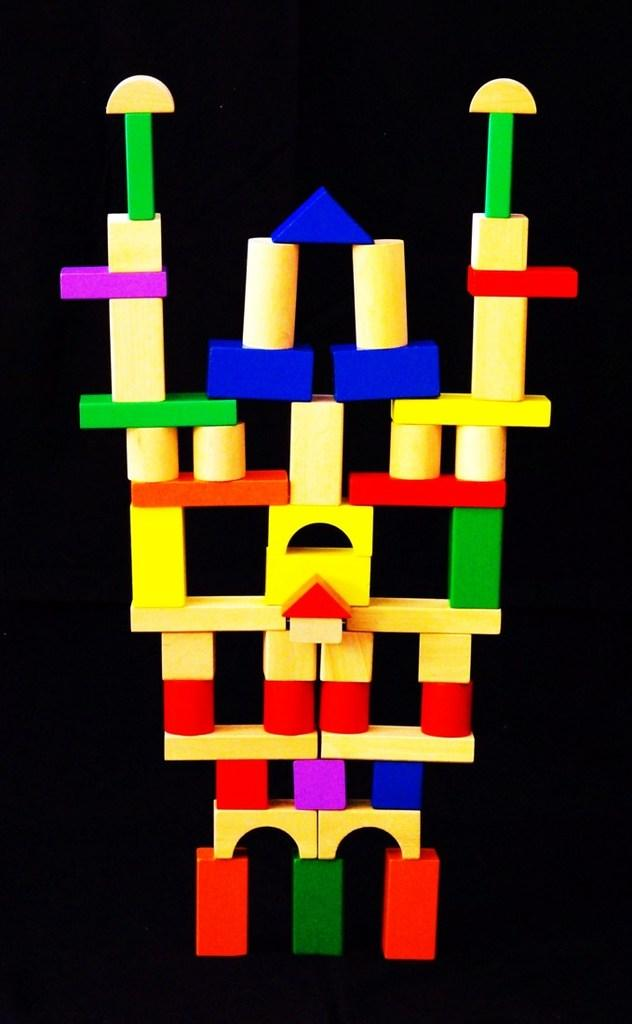What is the main subject of the image? The main subject of the image is a building made with blocks. What can be seen in the background of the image? The background of the image is dark. Can you see a stranger smiling in the image? There is no stranger or smile present in the image; it features a building made with blocks against a dark background. 